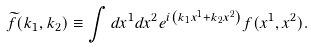<formula> <loc_0><loc_0><loc_500><loc_500>\widetilde { f } ( k _ { 1 } , k _ { 2 } ) \equiv \int d x ^ { 1 } d x ^ { 2 } e ^ { i \left ( k _ { 1 } x ^ { 1 } + k _ { 2 } x ^ { 2 } \right ) } f ( x ^ { 1 } , x ^ { 2 } ) .</formula> 